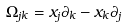<formula> <loc_0><loc_0><loc_500><loc_500>\Omega _ { j k } = x _ { j } \partial _ { k } - x _ { k } \partial _ { j }</formula> 